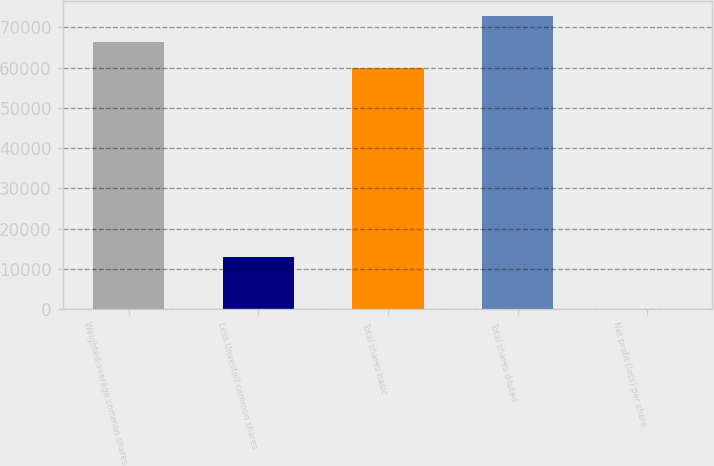<chart> <loc_0><loc_0><loc_500><loc_500><bar_chart><fcel>Weighted-average common shares<fcel>Less Unvested common shares<fcel>Total shares basic<fcel>Total shares diluted<fcel>Net profit (loss) per share<nl><fcel>66371.9<fcel>12817.9<fcel>59963<fcel>72780.8<fcel>0.14<nl></chart> 